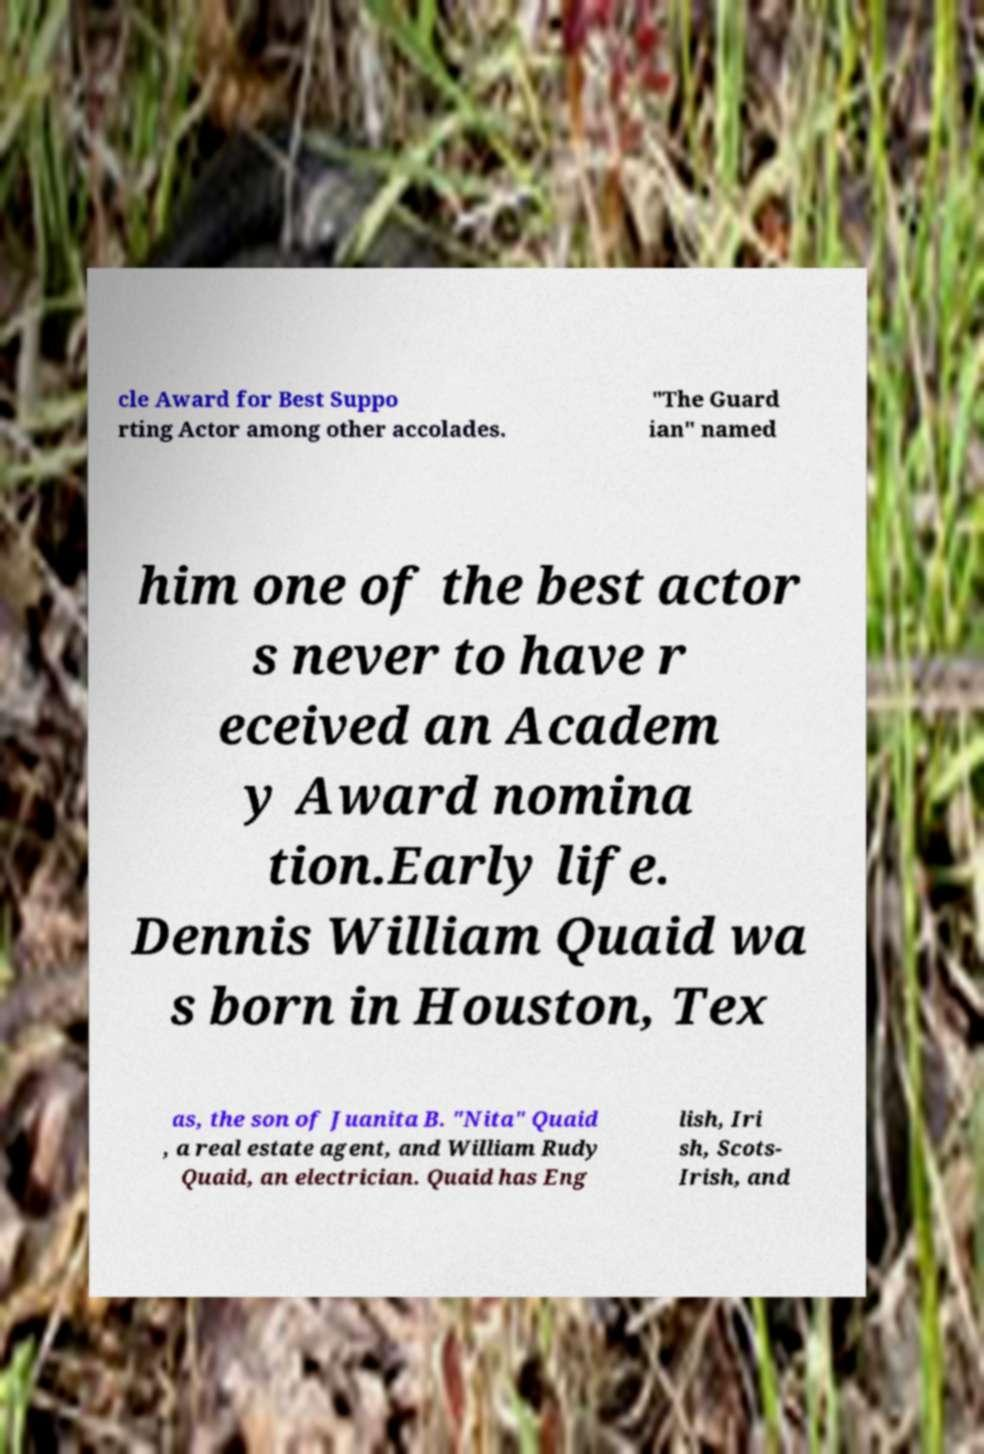There's text embedded in this image that I need extracted. Can you transcribe it verbatim? cle Award for Best Suppo rting Actor among other accolades. "The Guard ian" named him one of the best actor s never to have r eceived an Academ y Award nomina tion.Early life. Dennis William Quaid wa s born in Houston, Tex as, the son of Juanita B. "Nita" Quaid , a real estate agent, and William Rudy Quaid, an electrician. Quaid has Eng lish, Iri sh, Scots- Irish, and 